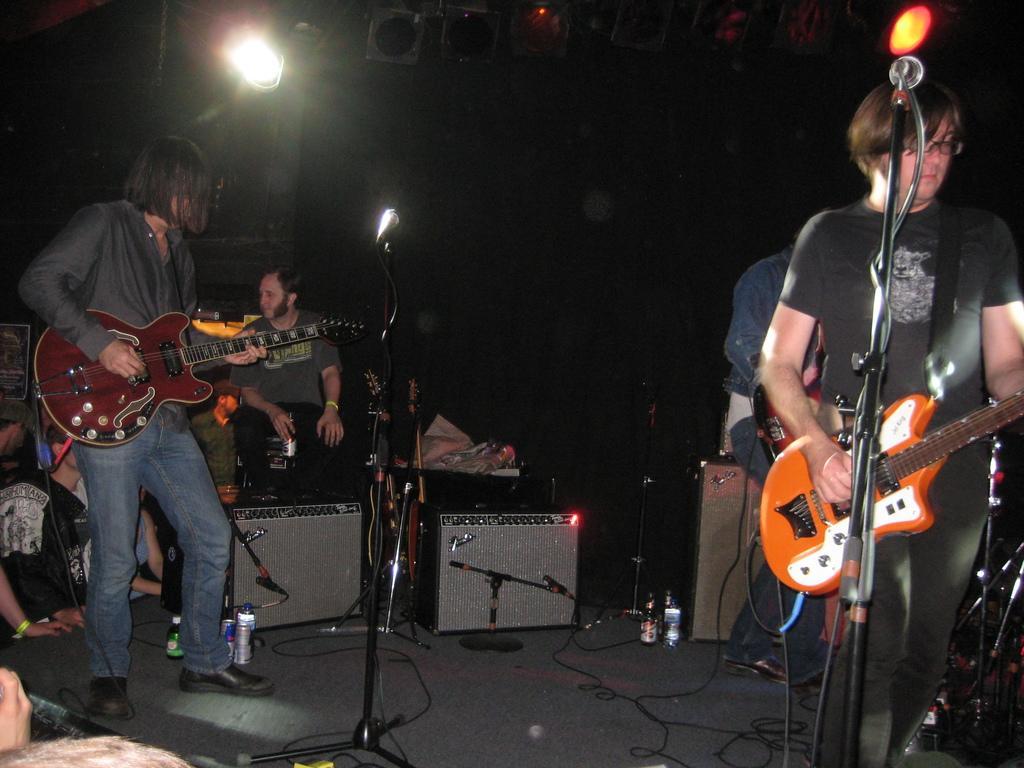Could you give a brief overview of what you see in this image? in this image i can see many people. there is a ,man standing at the right playing a guitar.. there is a microphone in front of him. at the left there is another man playing guitar wearing grey shirt and jeans. behind them there is a man sitting. on the floor there many bottles and cans. 